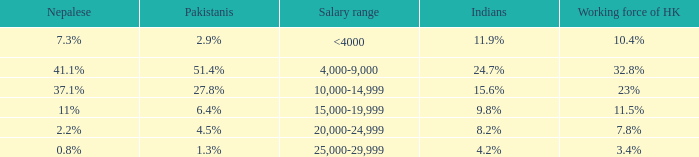If the nepalese is 37.1%, what is the working force of HK? 23%. 